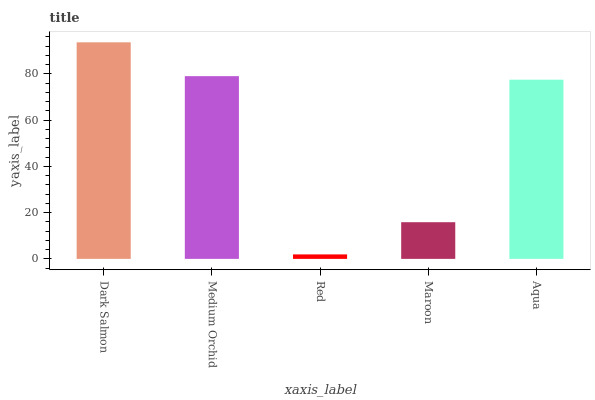Is Red the minimum?
Answer yes or no. Yes. Is Dark Salmon the maximum?
Answer yes or no. Yes. Is Medium Orchid the minimum?
Answer yes or no. No. Is Medium Orchid the maximum?
Answer yes or no. No. Is Dark Salmon greater than Medium Orchid?
Answer yes or no. Yes. Is Medium Orchid less than Dark Salmon?
Answer yes or no. Yes. Is Medium Orchid greater than Dark Salmon?
Answer yes or no. No. Is Dark Salmon less than Medium Orchid?
Answer yes or no. No. Is Aqua the high median?
Answer yes or no. Yes. Is Aqua the low median?
Answer yes or no. Yes. Is Red the high median?
Answer yes or no. No. Is Maroon the low median?
Answer yes or no. No. 